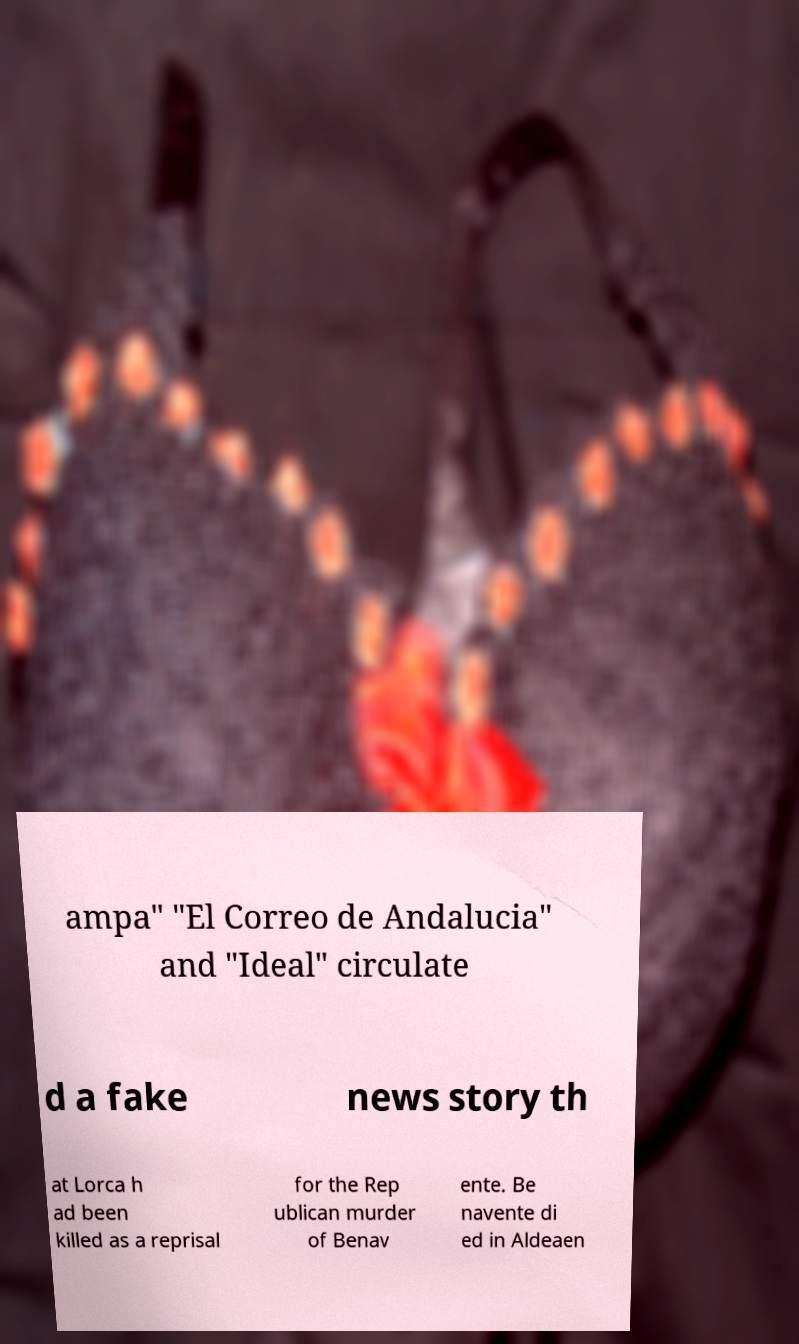Can you accurately transcribe the text from the provided image for me? ampa" "El Correo de Andalucia" and "Ideal" circulate d a fake news story th at Lorca h ad been killed as a reprisal for the Rep ublican murder of Benav ente. Be navente di ed in Aldeaen 